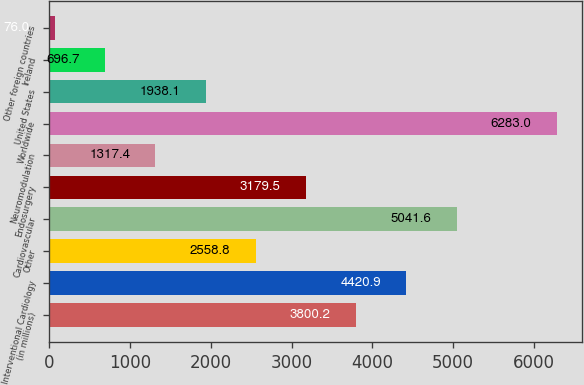<chart> <loc_0><loc_0><loc_500><loc_500><bar_chart><fcel>(in millions)<fcel>Interventional Cardiology<fcel>Other<fcel>Cardiovascular<fcel>Endosurgery<fcel>Neuromodulation<fcel>Worldwide<fcel>United States<fcel>Ireland<fcel>Other foreign countries<nl><fcel>3800.2<fcel>4420.9<fcel>2558.8<fcel>5041.6<fcel>3179.5<fcel>1317.4<fcel>6283<fcel>1938.1<fcel>696.7<fcel>76<nl></chart> 